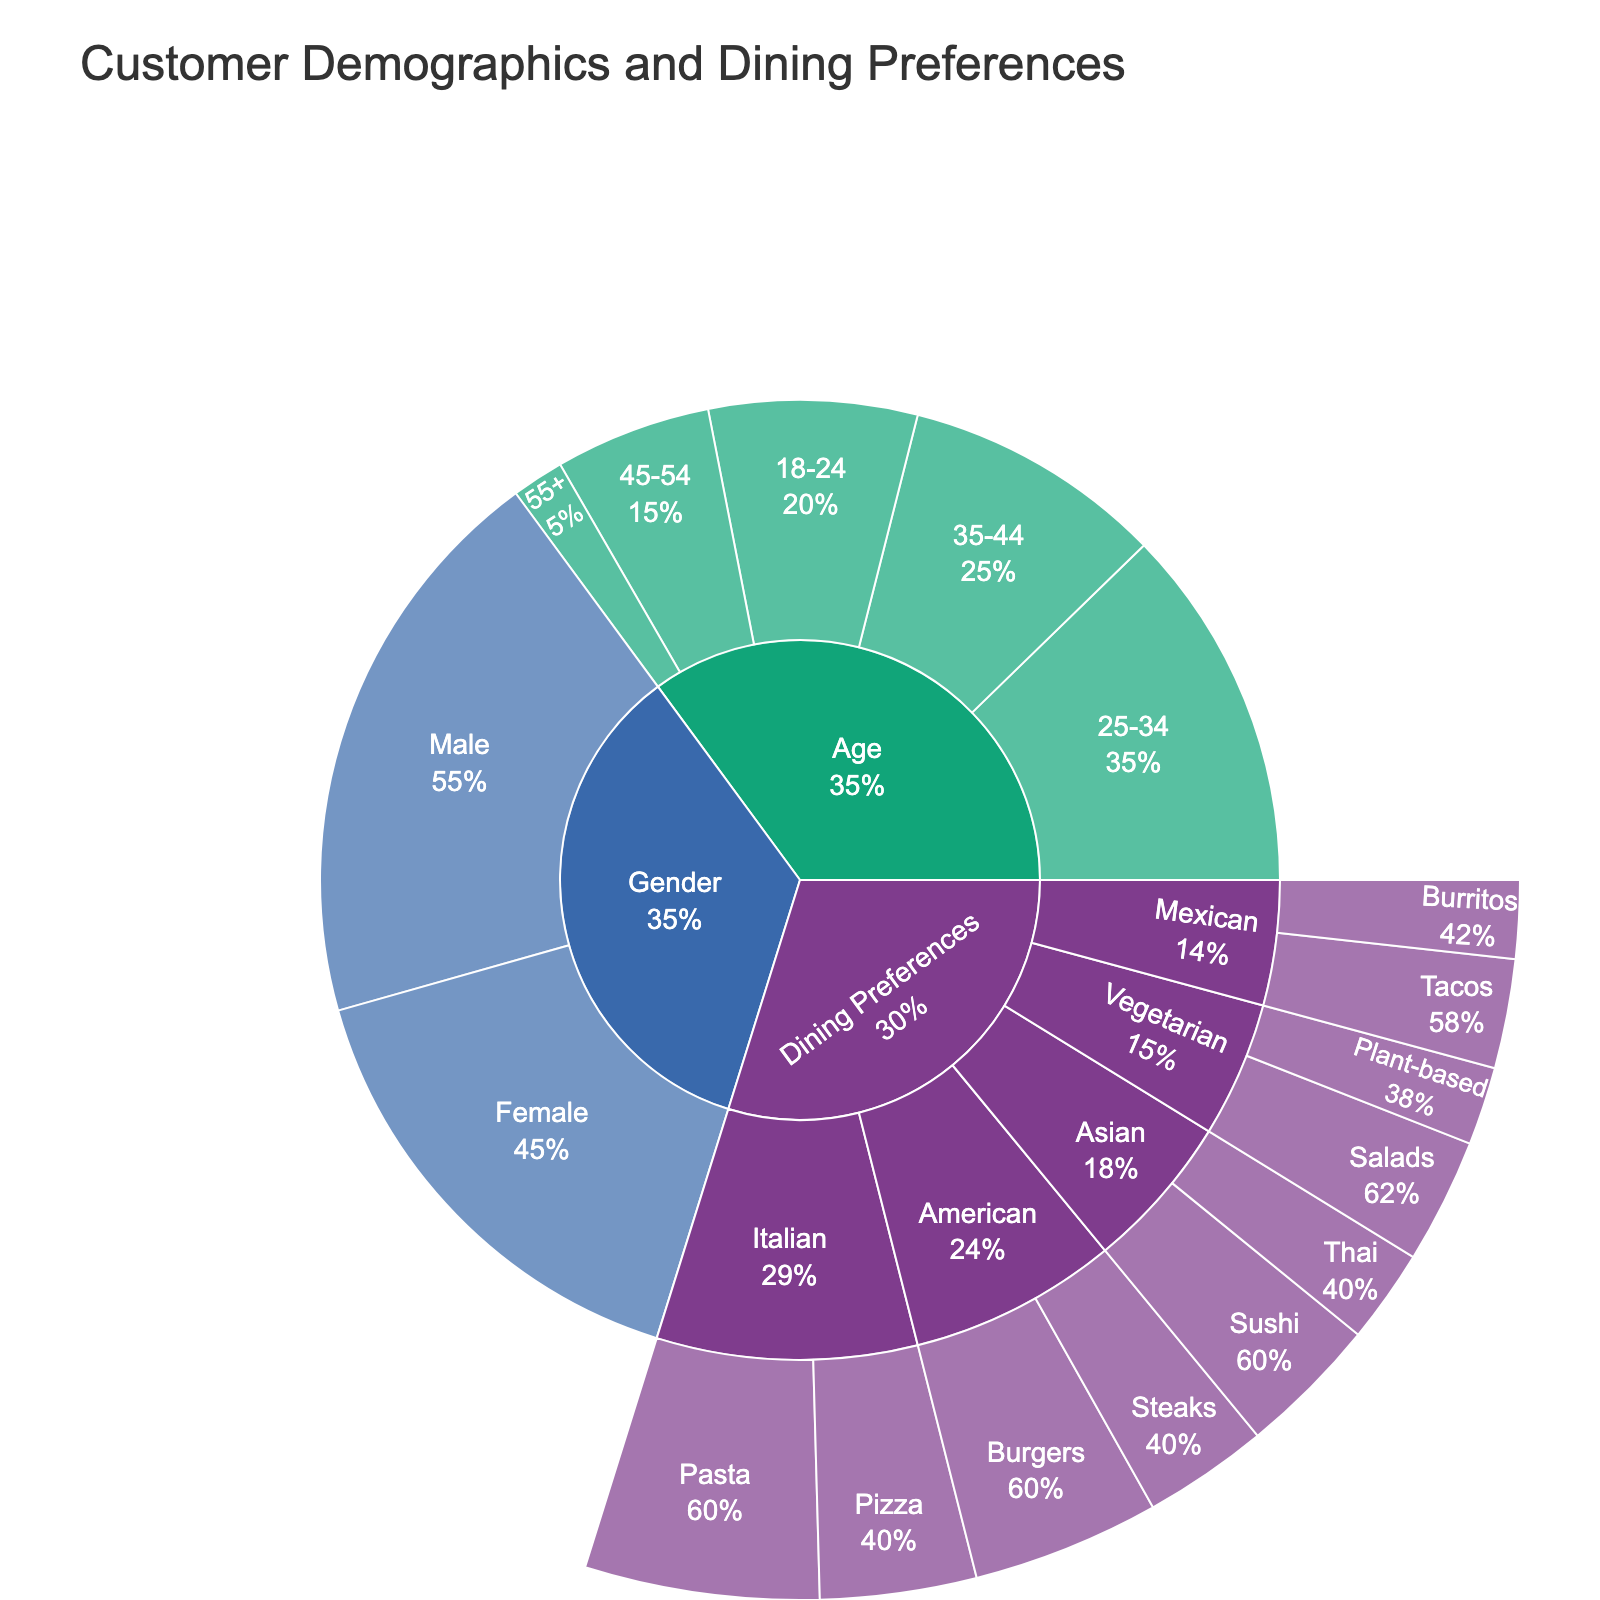What's the title of the figure? The title of the figure is prominently placed at the top, usually in larger font size. It provides a succinct description of what the figure represents.
Answer: Customer Demographics and Dining Preferences Which age group has the highest number of customers? By inspecting the age categories in the outer ring of the sunburst, the segment with the largest proportional area represents the age group with the highest value.
Answer: 25-34 What's the percentage of customers who prefer Burgers out of those who prefer American cuisine? Look at the segment for Burgers under American cuisine and compare its size to the entire American cuisine category. The hover text will also provide this percentage.
Answer: 60% How many categories are there in the plot? The sunburst plot is divided into several main categories, as indicated by the different colors. By counting the top-level segments, the number of main categories can be determined.
Answer: 3 What percentage of customers are female? Inspect the "Gender" category segment and look for the subsegment labeled "Female." The hover text reveals the percentage of female customers relative to the total gender category.
Answer: 45% What's the least preferred dining option overall? In the dining preferences category, identify the smallest segment in the outermost ring, as this would represent the least popular option.
Answer: Burritos What's the total number of vegetarian dining preference customers? Add up the values for Salads and Plant-based under the Vegetarian category (8 + 5).
Answer: 13 Which dining preference is more popular, Italian or Mexican? Compare the combined values of subcategories under Italian and Mexican. Italian's total is 25 (Pasta 15 + Pizza 10), while Mexican's total is 12 (Tacos 7 + Burritos 5).
Answer: Italian What age group encompasses 25% of the total customer base? Identify the segment whose proportional area corresponds to 25% when considering the entire age category. The hover text can also help with this detail.
Answer: 35-44 What dining preference is most popular among the Asian category? Within the Asian category, compare the subsegment sizes. The largest segment represents the most popular option.
Answer: Sushi 